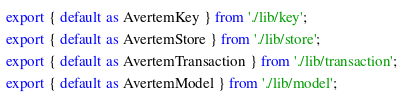<code> <loc_0><loc_0><loc_500><loc_500><_JavaScript_>
export { default as AvertemKey } from './lib/key';
export { default as AvertemStore } from './lib/store';
export { default as AvertemTransaction } from './lib/transaction';
export { default as AvertemModel } from './lib/model';
</code> 